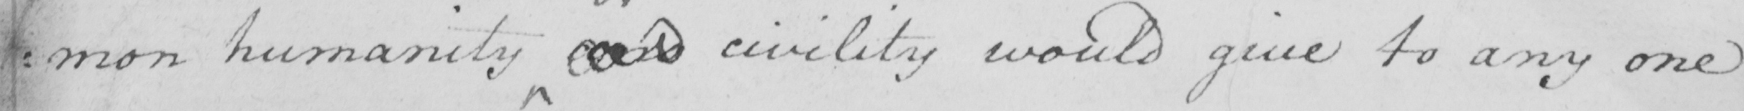Please transcribe the handwritten text in this image. : mon humanity and civility would give to any one 